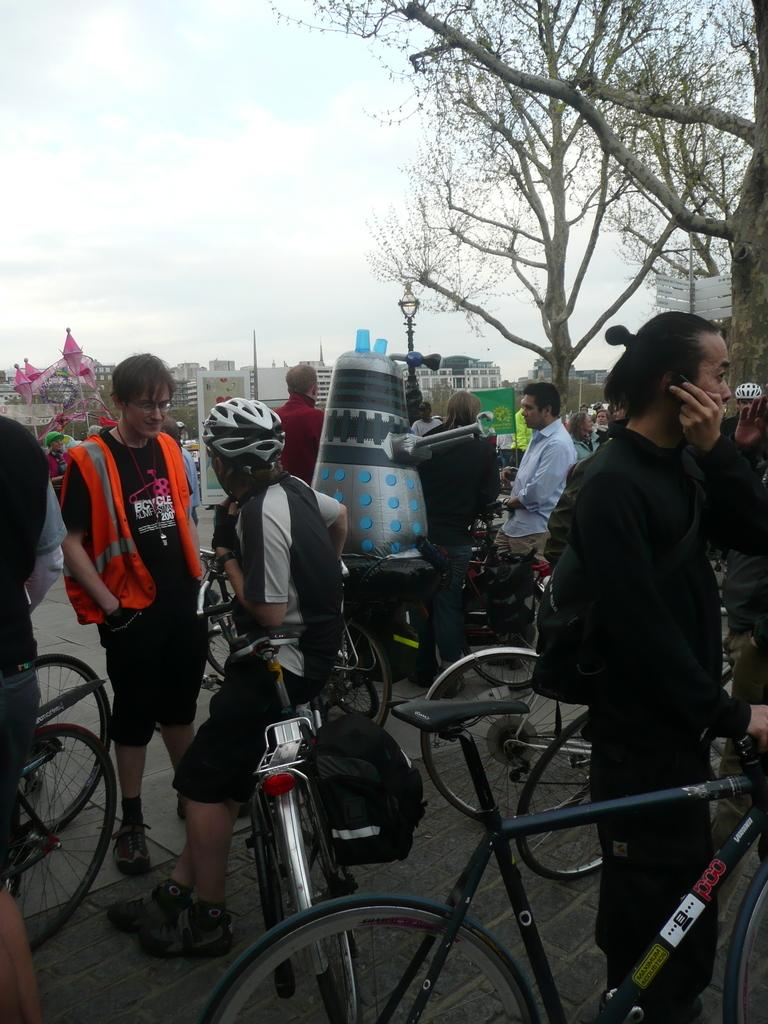Who or what can be seen in the image? There are people in the image. What are the people using in the image? There are cycles in the image. What can be seen in the distance in the image? There are trees, a street light, and buildings in the background of the image. What part of the natural environment is visible in the image? The sky is visible in the image. What color is the mountain in the image? There is no mountain present in the image. What phase is the moon in the image? There is no moon present in the image. 